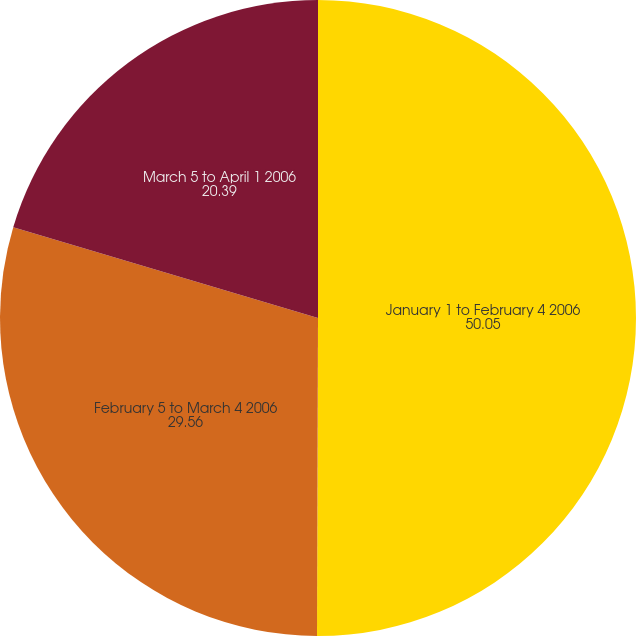Convert chart to OTSL. <chart><loc_0><loc_0><loc_500><loc_500><pie_chart><fcel>January 1 to February 4 2006<fcel>February 5 to March 4 2006<fcel>March 5 to April 1 2006<nl><fcel>50.05%<fcel>29.56%<fcel>20.39%<nl></chart> 